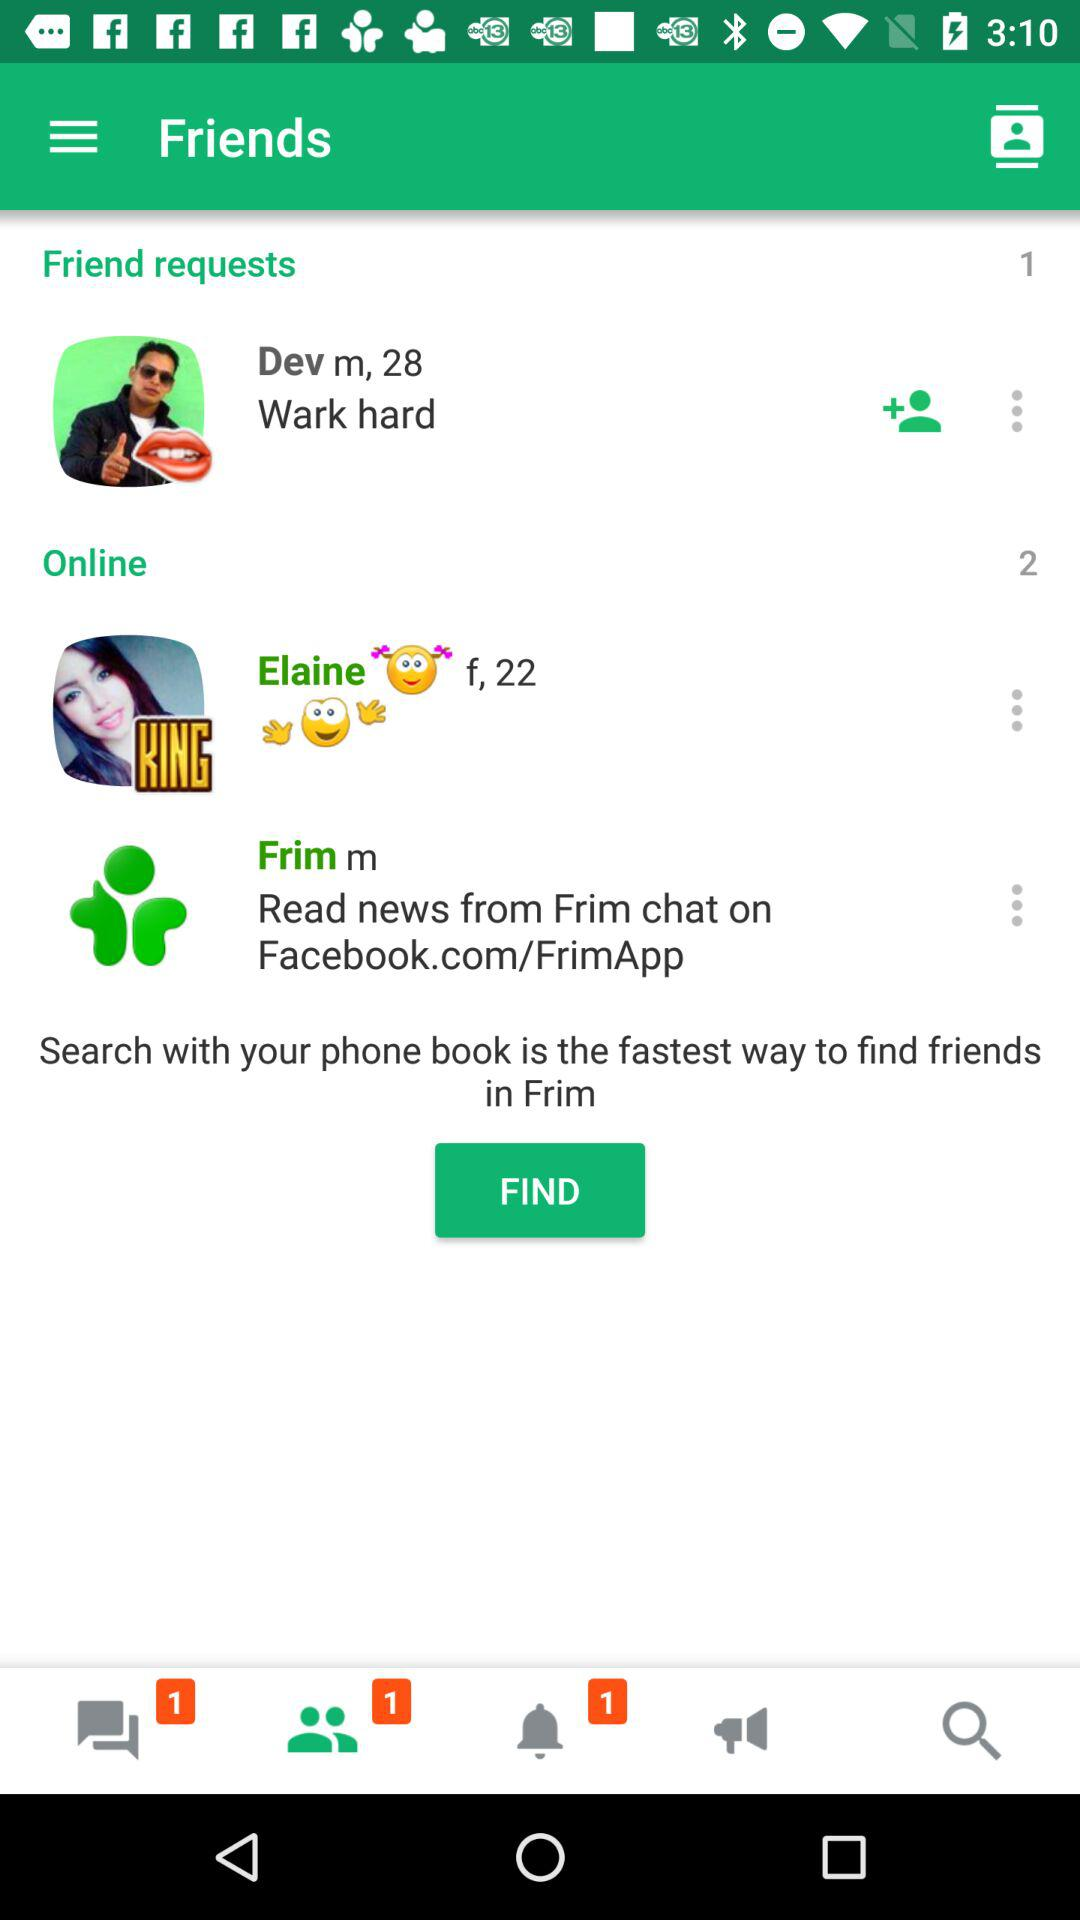What is the gender of Dev? The gender of Dev is male. 